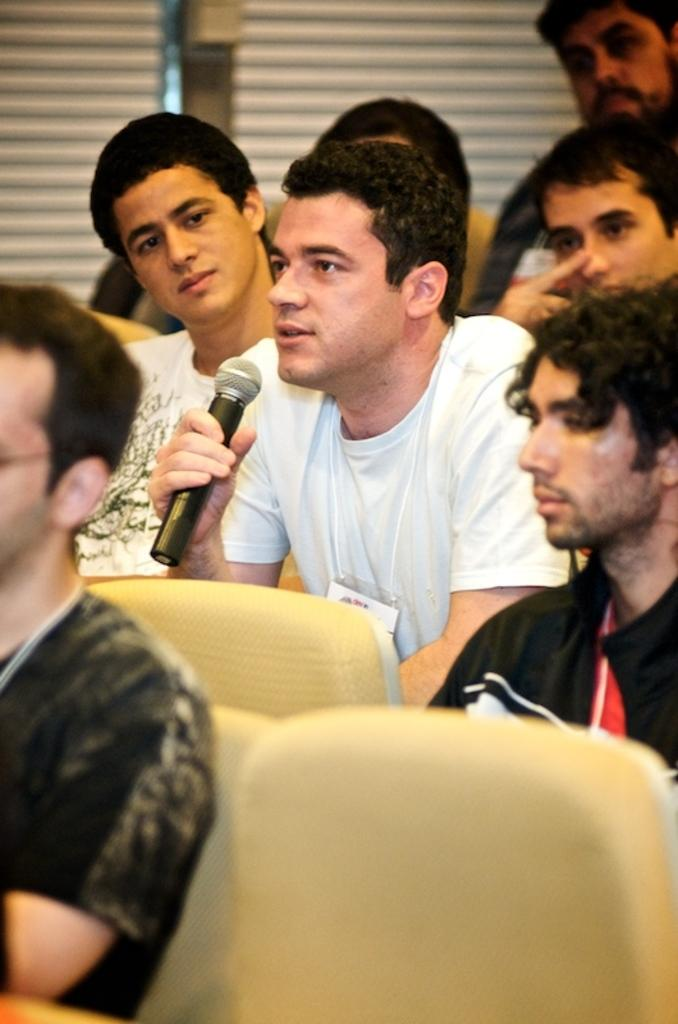Who can be seen in the image? There are people in the image. What are the people doing in the image? The people are sitting on chairs. Can you describe the man in the image? The man is holding a mic in the image. What type of linen is being used to cover the chairs in the image? There is no mention of linen or any chair coverings in the image. What type of pleasure can be seen on the faces of the people in the image? The image does not show the facial expressions of the people, so it is impossible to determine their emotions or pleasure. 